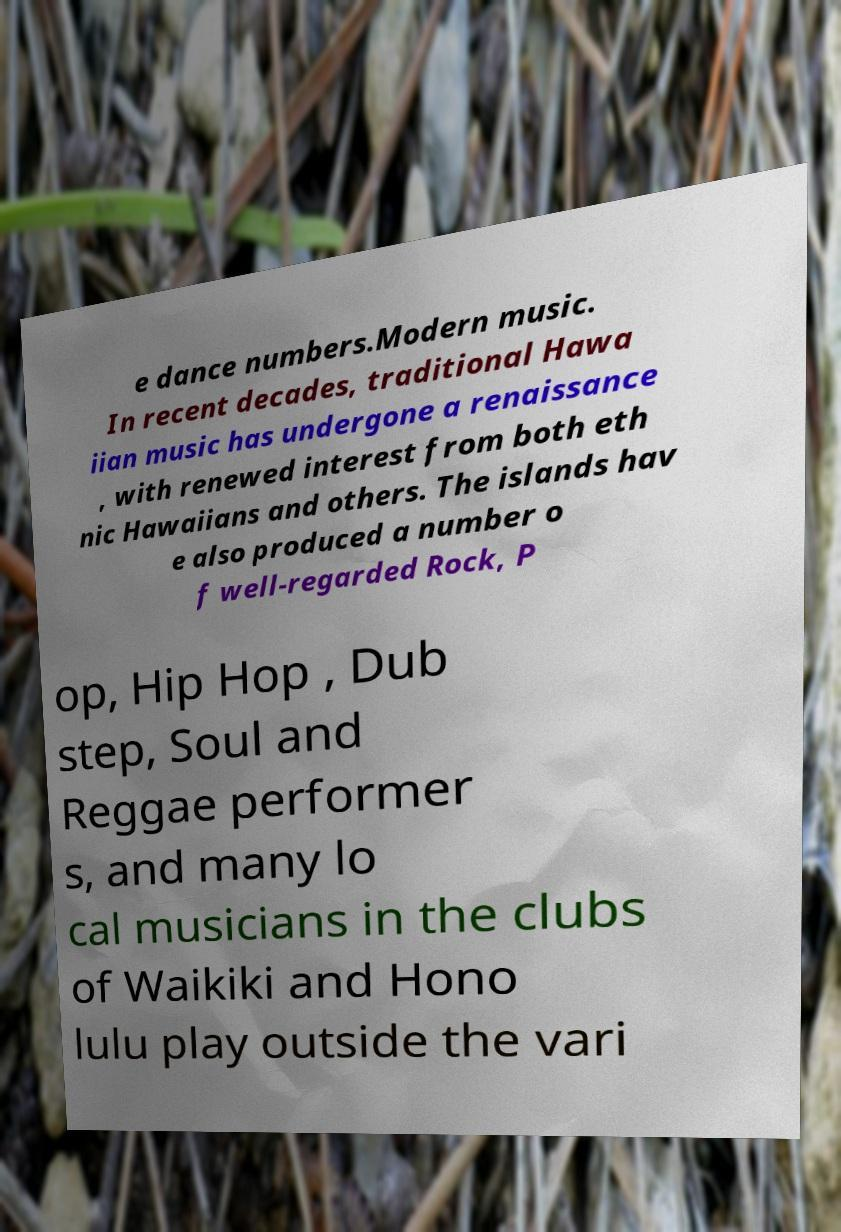There's text embedded in this image that I need extracted. Can you transcribe it verbatim? e dance numbers.Modern music. In recent decades, traditional Hawa iian music has undergone a renaissance , with renewed interest from both eth nic Hawaiians and others. The islands hav e also produced a number o f well-regarded Rock, P op, Hip Hop , Dub step, Soul and Reggae performer s, and many lo cal musicians in the clubs of Waikiki and Hono lulu play outside the vari 